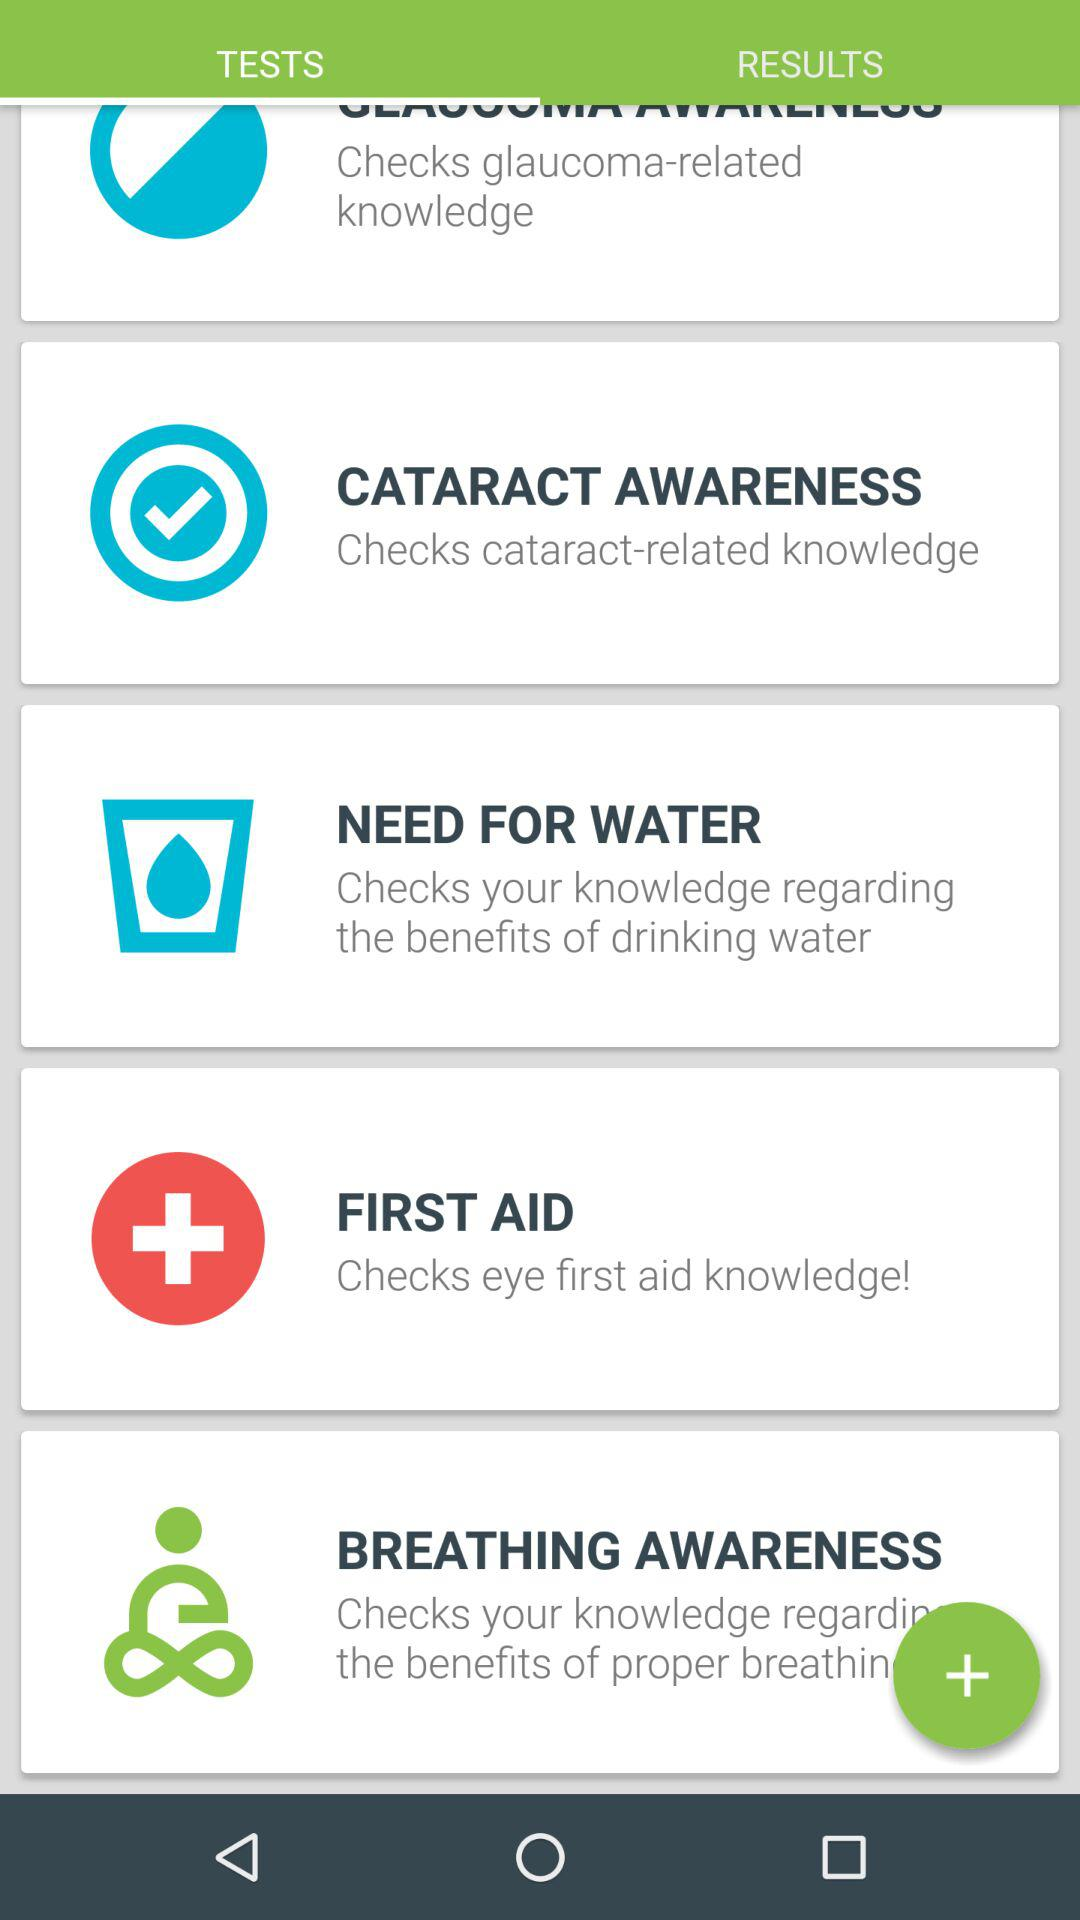Which tab has been selected? The selected tab is "TESTS". 